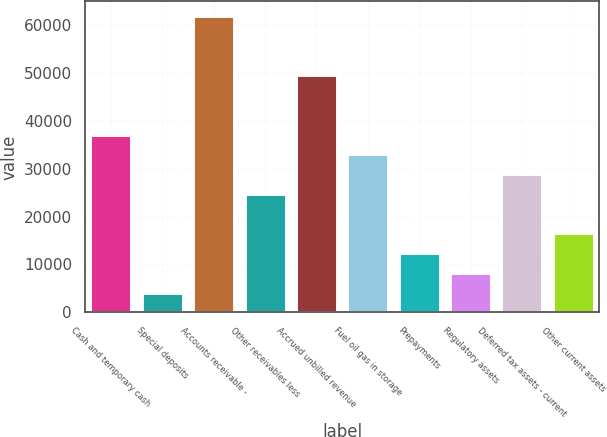<chart> <loc_0><loc_0><loc_500><loc_500><bar_chart><fcel>Cash and temporary cash<fcel>Special deposits<fcel>Accounts receivable -<fcel>Other receivables less<fcel>Accrued unbilled revenue<fcel>Fuel oil gas in storage<fcel>Prepayments<fcel>Regulatory assets<fcel>Deferred tax assets - current<fcel>Other current assets<nl><fcel>37088.3<fcel>4122.7<fcel>61812.5<fcel>24726.2<fcel>49450.4<fcel>32967.6<fcel>12364.1<fcel>8243.4<fcel>28846.9<fcel>16484.8<nl></chart> 